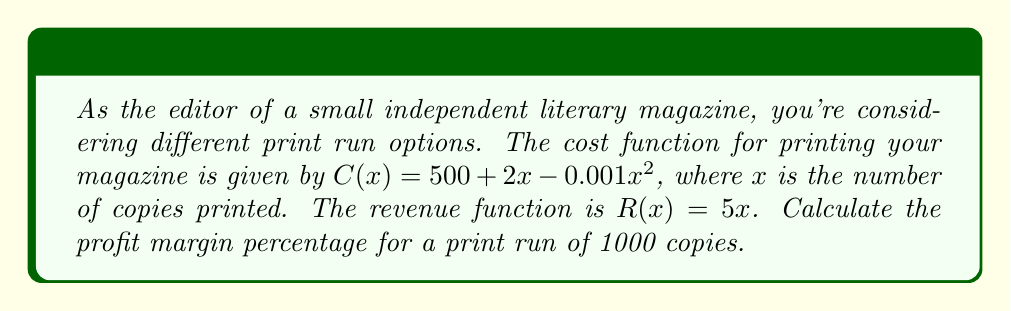Provide a solution to this math problem. Let's approach this step-by-step:

1) First, we need to calculate the profit function $P(x)$:
   $P(x) = R(x) - C(x)$
   $P(x) = 5x - (500 + 2x - 0.001x^2)$
   $P(x) = 5x - 500 - 2x + 0.001x^2$
   $P(x) = 3x - 500 + 0.001x^2$

2) Now, let's calculate the profit for 1000 copies:
   $P(1000) = 3(1000) - 500 + 0.001(1000^2)$
   $P(1000) = 3000 - 500 + 1000$
   $P(1000) = 3500$

3) Next, we need to calculate the revenue for 1000 copies:
   $R(1000) = 5(1000) = 5000$

4) The profit margin percentage is calculated as:
   Profit Margin % = $\frac{\text{Profit}}{\text{Revenue}} \times 100\%$

5) Substituting our values:
   Profit Margin % = $\frac{3500}{5000} \times 100\%$
                   = $0.7 \times 100\%$
                   = $70\%$
Answer: 70% 